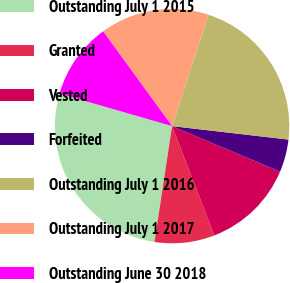Convert chart to OTSL. <chart><loc_0><loc_0><loc_500><loc_500><pie_chart><fcel>Outstanding July 1 2015<fcel>Granted<fcel>Vested<fcel>Forfeited<fcel>Outstanding July 1 2016<fcel>Outstanding July 1 2017<fcel>Outstanding June 30 2018<nl><fcel>27.07%<fcel>8.27%<fcel>12.78%<fcel>4.51%<fcel>21.8%<fcel>15.04%<fcel>10.53%<nl></chart> 